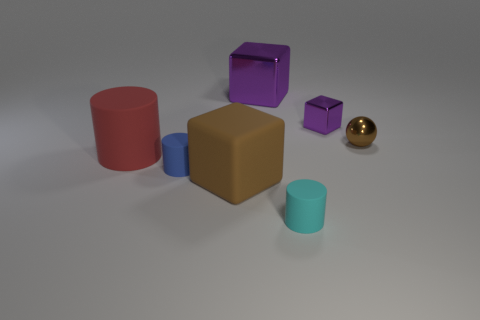Subtract 1 cubes. How many cubes are left? 2 Add 1 blue rubber objects. How many objects exist? 8 Subtract all small rubber cylinders. How many cylinders are left? 1 Subtract all balls. How many objects are left? 6 Add 5 tiny blue metal balls. How many tiny blue metal balls exist? 5 Subtract 0 green cylinders. How many objects are left? 7 Subtract all gray cylinders. Subtract all blue blocks. How many cylinders are left? 3 Subtract all small yellow matte blocks. Subtract all matte blocks. How many objects are left? 6 Add 4 small matte things. How many small matte things are left? 6 